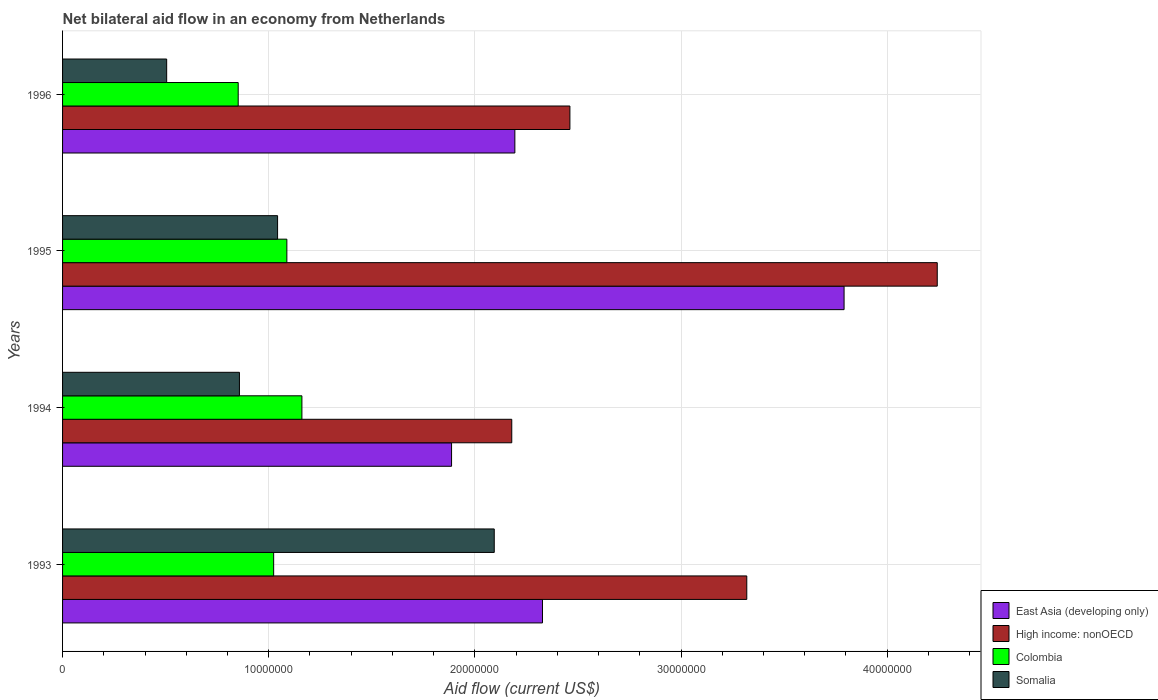How many different coloured bars are there?
Your response must be concise. 4. How many groups of bars are there?
Your response must be concise. 4. Are the number of bars on each tick of the Y-axis equal?
Make the answer very short. Yes. How many bars are there on the 3rd tick from the top?
Offer a very short reply. 4. In how many cases, is the number of bars for a given year not equal to the number of legend labels?
Your answer should be very brief. 0. What is the net bilateral aid flow in Colombia in 1994?
Ensure brevity in your answer.  1.16e+07. Across all years, what is the maximum net bilateral aid flow in Somalia?
Your answer should be very brief. 2.09e+07. Across all years, what is the minimum net bilateral aid flow in Somalia?
Ensure brevity in your answer.  5.05e+06. In which year was the net bilateral aid flow in Colombia maximum?
Your response must be concise. 1994. What is the total net bilateral aid flow in Colombia in the graph?
Your response must be concise. 4.12e+07. What is the difference between the net bilateral aid flow in Somalia in 1994 and that in 1995?
Provide a short and direct response. -1.85e+06. What is the difference between the net bilateral aid flow in Somalia in 1993 and the net bilateral aid flow in High income: nonOECD in 1996?
Provide a short and direct response. -3.67e+06. What is the average net bilateral aid flow in East Asia (developing only) per year?
Your answer should be compact. 2.55e+07. In the year 1993, what is the difference between the net bilateral aid flow in High income: nonOECD and net bilateral aid flow in Somalia?
Provide a short and direct response. 1.22e+07. In how many years, is the net bilateral aid flow in Colombia greater than 38000000 US$?
Keep it short and to the point. 0. What is the ratio of the net bilateral aid flow in East Asia (developing only) in 1994 to that in 1996?
Offer a terse response. 0.86. What is the difference between the highest and the second highest net bilateral aid flow in High income: nonOECD?
Your answer should be compact. 9.24e+06. What is the difference between the highest and the lowest net bilateral aid flow in High income: nonOECD?
Ensure brevity in your answer.  2.06e+07. Is the sum of the net bilateral aid flow in East Asia (developing only) in 1993 and 1996 greater than the maximum net bilateral aid flow in Somalia across all years?
Give a very brief answer. Yes. Is it the case that in every year, the sum of the net bilateral aid flow in East Asia (developing only) and net bilateral aid flow in High income: nonOECD is greater than the sum of net bilateral aid flow in Somalia and net bilateral aid flow in Colombia?
Give a very brief answer. Yes. What does the 2nd bar from the top in 1993 represents?
Provide a short and direct response. Colombia. What does the 2nd bar from the bottom in 1995 represents?
Make the answer very short. High income: nonOECD. How many bars are there?
Your answer should be very brief. 16. Are all the bars in the graph horizontal?
Your answer should be compact. Yes. What is the difference between two consecutive major ticks on the X-axis?
Provide a succinct answer. 1.00e+07. Are the values on the major ticks of X-axis written in scientific E-notation?
Offer a very short reply. No. Does the graph contain any zero values?
Make the answer very short. No. Does the graph contain grids?
Provide a succinct answer. Yes. How many legend labels are there?
Keep it short and to the point. 4. How are the legend labels stacked?
Your response must be concise. Vertical. What is the title of the graph?
Offer a terse response. Net bilateral aid flow in an economy from Netherlands. What is the label or title of the X-axis?
Keep it short and to the point. Aid flow (current US$). What is the label or title of the Y-axis?
Provide a short and direct response. Years. What is the Aid flow (current US$) of East Asia (developing only) in 1993?
Keep it short and to the point. 2.33e+07. What is the Aid flow (current US$) in High income: nonOECD in 1993?
Offer a terse response. 3.32e+07. What is the Aid flow (current US$) of Colombia in 1993?
Your response must be concise. 1.02e+07. What is the Aid flow (current US$) of Somalia in 1993?
Keep it short and to the point. 2.09e+07. What is the Aid flow (current US$) in East Asia (developing only) in 1994?
Offer a very short reply. 1.89e+07. What is the Aid flow (current US$) in High income: nonOECD in 1994?
Offer a terse response. 2.18e+07. What is the Aid flow (current US$) in Colombia in 1994?
Keep it short and to the point. 1.16e+07. What is the Aid flow (current US$) of Somalia in 1994?
Provide a succinct answer. 8.58e+06. What is the Aid flow (current US$) in East Asia (developing only) in 1995?
Provide a succinct answer. 3.79e+07. What is the Aid flow (current US$) of High income: nonOECD in 1995?
Offer a terse response. 4.24e+07. What is the Aid flow (current US$) in Colombia in 1995?
Give a very brief answer. 1.09e+07. What is the Aid flow (current US$) in Somalia in 1995?
Your response must be concise. 1.04e+07. What is the Aid flow (current US$) of East Asia (developing only) in 1996?
Give a very brief answer. 2.19e+07. What is the Aid flow (current US$) in High income: nonOECD in 1996?
Offer a very short reply. 2.46e+07. What is the Aid flow (current US$) in Colombia in 1996?
Offer a terse response. 8.52e+06. What is the Aid flow (current US$) in Somalia in 1996?
Your answer should be compact. 5.05e+06. Across all years, what is the maximum Aid flow (current US$) of East Asia (developing only)?
Keep it short and to the point. 3.79e+07. Across all years, what is the maximum Aid flow (current US$) in High income: nonOECD?
Make the answer very short. 4.24e+07. Across all years, what is the maximum Aid flow (current US$) in Colombia?
Your response must be concise. 1.16e+07. Across all years, what is the maximum Aid flow (current US$) of Somalia?
Your answer should be compact. 2.09e+07. Across all years, what is the minimum Aid flow (current US$) in East Asia (developing only)?
Keep it short and to the point. 1.89e+07. Across all years, what is the minimum Aid flow (current US$) of High income: nonOECD?
Your response must be concise. 2.18e+07. Across all years, what is the minimum Aid flow (current US$) of Colombia?
Your answer should be very brief. 8.52e+06. Across all years, what is the minimum Aid flow (current US$) in Somalia?
Offer a terse response. 5.05e+06. What is the total Aid flow (current US$) in East Asia (developing only) in the graph?
Make the answer very short. 1.02e+08. What is the total Aid flow (current US$) in High income: nonOECD in the graph?
Make the answer very short. 1.22e+08. What is the total Aid flow (current US$) of Colombia in the graph?
Give a very brief answer. 4.12e+07. What is the total Aid flow (current US$) of Somalia in the graph?
Ensure brevity in your answer.  4.50e+07. What is the difference between the Aid flow (current US$) in East Asia (developing only) in 1993 and that in 1994?
Keep it short and to the point. 4.41e+06. What is the difference between the Aid flow (current US$) of High income: nonOECD in 1993 and that in 1994?
Your answer should be compact. 1.14e+07. What is the difference between the Aid flow (current US$) of Colombia in 1993 and that in 1994?
Keep it short and to the point. -1.37e+06. What is the difference between the Aid flow (current US$) in Somalia in 1993 and that in 1994?
Your answer should be very brief. 1.24e+07. What is the difference between the Aid flow (current US$) in East Asia (developing only) in 1993 and that in 1995?
Keep it short and to the point. -1.46e+07. What is the difference between the Aid flow (current US$) of High income: nonOECD in 1993 and that in 1995?
Give a very brief answer. -9.24e+06. What is the difference between the Aid flow (current US$) of Colombia in 1993 and that in 1995?
Keep it short and to the point. -6.40e+05. What is the difference between the Aid flow (current US$) in Somalia in 1993 and that in 1995?
Your answer should be very brief. 1.05e+07. What is the difference between the Aid flow (current US$) in East Asia (developing only) in 1993 and that in 1996?
Give a very brief answer. 1.34e+06. What is the difference between the Aid flow (current US$) in High income: nonOECD in 1993 and that in 1996?
Offer a terse response. 8.58e+06. What is the difference between the Aid flow (current US$) of Colombia in 1993 and that in 1996?
Your response must be concise. 1.72e+06. What is the difference between the Aid flow (current US$) of Somalia in 1993 and that in 1996?
Your response must be concise. 1.59e+07. What is the difference between the Aid flow (current US$) of East Asia (developing only) in 1994 and that in 1995?
Ensure brevity in your answer.  -1.90e+07. What is the difference between the Aid flow (current US$) of High income: nonOECD in 1994 and that in 1995?
Offer a very short reply. -2.06e+07. What is the difference between the Aid flow (current US$) of Colombia in 1994 and that in 1995?
Ensure brevity in your answer.  7.30e+05. What is the difference between the Aid flow (current US$) in Somalia in 1994 and that in 1995?
Provide a succinct answer. -1.85e+06. What is the difference between the Aid flow (current US$) in East Asia (developing only) in 1994 and that in 1996?
Provide a short and direct response. -3.07e+06. What is the difference between the Aid flow (current US$) of High income: nonOECD in 1994 and that in 1996?
Give a very brief answer. -2.82e+06. What is the difference between the Aid flow (current US$) in Colombia in 1994 and that in 1996?
Provide a succinct answer. 3.09e+06. What is the difference between the Aid flow (current US$) in Somalia in 1994 and that in 1996?
Keep it short and to the point. 3.53e+06. What is the difference between the Aid flow (current US$) of East Asia (developing only) in 1995 and that in 1996?
Your answer should be very brief. 1.60e+07. What is the difference between the Aid flow (current US$) in High income: nonOECD in 1995 and that in 1996?
Provide a short and direct response. 1.78e+07. What is the difference between the Aid flow (current US$) of Colombia in 1995 and that in 1996?
Ensure brevity in your answer.  2.36e+06. What is the difference between the Aid flow (current US$) in Somalia in 1995 and that in 1996?
Make the answer very short. 5.38e+06. What is the difference between the Aid flow (current US$) of East Asia (developing only) in 1993 and the Aid flow (current US$) of High income: nonOECD in 1994?
Provide a short and direct response. 1.49e+06. What is the difference between the Aid flow (current US$) of East Asia (developing only) in 1993 and the Aid flow (current US$) of Colombia in 1994?
Keep it short and to the point. 1.17e+07. What is the difference between the Aid flow (current US$) of East Asia (developing only) in 1993 and the Aid flow (current US$) of Somalia in 1994?
Your response must be concise. 1.47e+07. What is the difference between the Aid flow (current US$) in High income: nonOECD in 1993 and the Aid flow (current US$) in Colombia in 1994?
Your answer should be very brief. 2.16e+07. What is the difference between the Aid flow (current US$) of High income: nonOECD in 1993 and the Aid flow (current US$) of Somalia in 1994?
Your answer should be very brief. 2.46e+07. What is the difference between the Aid flow (current US$) in Colombia in 1993 and the Aid flow (current US$) in Somalia in 1994?
Ensure brevity in your answer.  1.66e+06. What is the difference between the Aid flow (current US$) of East Asia (developing only) in 1993 and the Aid flow (current US$) of High income: nonOECD in 1995?
Give a very brief answer. -1.92e+07. What is the difference between the Aid flow (current US$) of East Asia (developing only) in 1993 and the Aid flow (current US$) of Colombia in 1995?
Your answer should be compact. 1.24e+07. What is the difference between the Aid flow (current US$) of East Asia (developing only) in 1993 and the Aid flow (current US$) of Somalia in 1995?
Provide a succinct answer. 1.28e+07. What is the difference between the Aid flow (current US$) in High income: nonOECD in 1993 and the Aid flow (current US$) in Colombia in 1995?
Offer a terse response. 2.23e+07. What is the difference between the Aid flow (current US$) in High income: nonOECD in 1993 and the Aid flow (current US$) in Somalia in 1995?
Provide a short and direct response. 2.28e+07. What is the difference between the Aid flow (current US$) of Colombia in 1993 and the Aid flow (current US$) of Somalia in 1995?
Make the answer very short. -1.90e+05. What is the difference between the Aid flow (current US$) in East Asia (developing only) in 1993 and the Aid flow (current US$) in High income: nonOECD in 1996?
Make the answer very short. -1.33e+06. What is the difference between the Aid flow (current US$) of East Asia (developing only) in 1993 and the Aid flow (current US$) of Colombia in 1996?
Provide a succinct answer. 1.48e+07. What is the difference between the Aid flow (current US$) in East Asia (developing only) in 1993 and the Aid flow (current US$) in Somalia in 1996?
Offer a very short reply. 1.82e+07. What is the difference between the Aid flow (current US$) of High income: nonOECD in 1993 and the Aid flow (current US$) of Colombia in 1996?
Provide a succinct answer. 2.47e+07. What is the difference between the Aid flow (current US$) in High income: nonOECD in 1993 and the Aid flow (current US$) in Somalia in 1996?
Your response must be concise. 2.81e+07. What is the difference between the Aid flow (current US$) in Colombia in 1993 and the Aid flow (current US$) in Somalia in 1996?
Make the answer very short. 5.19e+06. What is the difference between the Aid flow (current US$) of East Asia (developing only) in 1994 and the Aid flow (current US$) of High income: nonOECD in 1995?
Your answer should be compact. -2.36e+07. What is the difference between the Aid flow (current US$) in East Asia (developing only) in 1994 and the Aid flow (current US$) in Colombia in 1995?
Ensure brevity in your answer.  7.99e+06. What is the difference between the Aid flow (current US$) of East Asia (developing only) in 1994 and the Aid flow (current US$) of Somalia in 1995?
Provide a succinct answer. 8.44e+06. What is the difference between the Aid flow (current US$) of High income: nonOECD in 1994 and the Aid flow (current US$) of Colombia in 1995?
Your response must be concise. 1.09e+07. What is the difference between the Aid flow (current US$) in High income: nonOECD in 1994 and the Aid flow (current US$) in Somalia in 1995?
Make the answer very short. 1.14e+07. What is the difference between the Aid flow (current US$) in Colombia in 1994 and the Aid flow (current US$) in Somalia in 1995?
Your answer should be very brief. 1.18e+06. What is the difference between the Aid flow (current US$) of East Asia (developing only) in 1994 and the Aid flow (current US$) of High income: nonOECD in 1996?
Your response must be concise. -5.74e+06. What is the difference between the Aid flow (current US$) of East Asia (developing only) in 1994 and the Aid flow (current US$) of Colombia in 1996?
Give a very brief answer. 1.04e+07. What is the difference between the Aid flow (current US$) in East Asia (developing only) in 1994 and the Aid flow (current US$) in Somalia in 1996?
Your response must be concise. 1.38e+07. What is the difference between the Aid flow (current US$) of High income: nonOECD in 1994 and the Aid flow (current US$) of Colombia in 1996?
Offer a terse response. 1.33e+07. What is the difference between the Aid flow (current US$) of High income: nonOECD in 1994 and the Aid flow (current US$) of Somalia in 1996?
Offer a terse response. 1.67e+07. What is the difference between the Aid flow (current US$) of Colombia in 1994 and the Aid flow (current US$) of Somalia in 1996?
Keep it short and to the point. 6.56e+06. What is the difference between the Aid flow (current US$) of East Asia (developing only) in 1995 and the Aid flow (current US$) of High income: nonOECD in 1996?
Give a very brief answer. 1.33e+07. What is the difference between the Aid flow (current US$) of East Asia (developing only) in 1995 and the Aid flow (current US$) of Colombia in 1996?
Provide a short and direct response. 2.94e+07. What is the difference between the Aid flow (current US$) in East Asia (developing only) in 1995 and the Aid flow (current US$) in Somalia in 1996?
Your answer should be very brief. 3.29e+07. What is the difference between the Aid flow (current US$) in High income: nonOECD in 1995 and the Aid flow (current US$) in Colombia in 1996?
Provide a succinct answer. 3.39e+07. What is the difference between the Aid flow (current US$) in High income: nonOECD in 1995 and the Aid flow (current US$) in Somalia in 1996?
Your answer should be very brief. 3.74e+07. What is the difference between the Aid flow (current US$) of Colombia in 1995 and the Aid flow (current US$) of Somalia in 1996?
Offer a very short reply. 5.83e+06. What is the average Aid flow (current US$) in East Asia (developing only) per year?
Make the answer very short. 2.55e+07. What is the average Aid flow (current US$) of High income: nonOECD per year?
Give a very brief answer. 3.05e+07. What is the average Aid flow (current US$) in Colombia per year?
Your answer should be very brief. 1.03e+07. What is the average Aid flow (current US$) of Somalia per year?
Give a very brief answer. 1.12e+07. In the year 1993, what is the difference between the Aid flow (current US$) in East Asia (developing only) and Aid flow (current US$) in High income: nonOECD?
Your answer should be compact. -9.91e+06. In the year 1993, what is the difference between the Aid flow (current US$) in East Asia (developing only) and Aid flow (current US$) in Colombia?
Offer a terse response. 1.30e+07. In the year 1993, what is the difference between the Aid flow (current US$) in East Asia (developing only) and Aid flow (current US$) in Somalia?
Keep it short and to the point. 2.34e+06. In the year 1993, what is the difference between the Aid flow (current US$) in High income: nonOECD and Aid flow (current US$) in Colombia?
Provide a succinct answer. 2.30e+07. In the year 1993, what is the difference between the Aid flow (current US$) of High income: nonOECD and Aid flow (current US$) of Somalia?
Offer a very short reply. 1.22e+07. In the year 1993, what is the difference between the Aid flow (current US$) in Colombia and Aid flow (current US$) in Somalia?
Your answer should be very brief. -1.07e+07. In the year 1994, what is the difference between the Aid flow (current US$) in East Asia (developing only) and Aid flow (current US$) in High income: nonOECD?
Provide a succinct answer. -2.92e+06. In the year 1994, what is the difference between the Aid flow (current US$) of East Asia (developing only) and Aid flow (current US$) of Colombia?
Provide a short and direct response. 7.26e+06. In the year 1994, what is the difference between the Aid flow (current US$) in East Asia (developing only) and Aid flow (current US$) in Somalia?
Ensure brevity in your answer.  1.03e+07. In the year 1994, what is the difference between the Aid flow (current US$) in High income: nonOECD and Aid flow (current US$) in Colombia?
Your response must be concise. 1.02e+07. In the year 1994, what is the difference between the Aid flow (current US$) of High income: nonOECD and Aid flow (current US$) of Somalia?
Your answer should be compact. 1.32e+07. In the year 1994, what is the difference between the Aid flow (current US$) of Colombia and Aid flow (current US$) of Somalia?
Offer a very short reply. 3.03e+06. In the year 1995, what is the difference between the Aid flow (current US$) of East Asia (developing only) and Aid flow (current US$) of High income: nonOECD?
Your answer should be very brief. -4.52e+06. In the year 1995, what is the difference between the Aid flow (current US$) of East Asia (developing only) and Aid flow (current US$) of Colombia?
Keep it short and to the point. 2.70e+07. In the year 1995, what is the difference between the Aid flow (current US$) of East Asia (developing only) and Aid flow (current US$) of Somalia?
Your answer should be compact. 2.75e+07. In the year 1995, what is the difference between the Aid flow (current US$) in High income: nonOECD and Aid flow (current US$) in Colombia?
Give a very brief answer. 3.16e+07. In the year 1995, what is the difference between the Aid flow (current US$) of High income: nonOECD and Aid flow (current US$) of Somalia?
Make the answer very short. 3.20e+07. In the year 1996, what is the difference between the Aid flow (current US$) of East Asia (developing only) and Aid flow (current US$) of High income: nonOECD?
Give a very brief answer. -2.67e+06. In the year 1996, what is the difference between the Aid flow (current US$) of East Asia (developing only) and Aid flow (current US$) of Colombia?
Your answer should be very brief. 1.34e+07. In the year 1996, what is the difference between the Aid flow (current US$) of East Asia (developing only) and Aid flow (current US$) of Somalia?
Make the answer very short. 1.69e+07. In the year 1996, what is the difference between the Aid flow (current US$) in High income: nonOECD and Aid flow (current US$) in Colombia?
Your answer should be compact. 1.61e+07. In the year 1996, what is the difference between the Aid flow (current US$) in High income: nonOECD and Aid flow (current US$) in Somalia?
Provide a succinct answer. 1.96e+07. In the year 1996, what is the difference between the Aid flow (current US$) in Colombia and Aid flow (current US$) in Somalia?
Provide a succinct answer. 3.47e+06. What is the ratio of the Aid flow (current US$) in East Asia (developing only) in 1993 to that in 1994?
Ensure brevity in your answer.  1.23. What is the ratio of the Aid flow (current US$) in High income: nonOECD in 1993 to that in 1994?
Your answer should be very brief. 1.52. What is the ratio of the Aid flow (current US$) of Colombia in 1993 to that in 1994?
Provide a short and direct response. 0.88. What is the ratio of the Aid flow (current US$) of Somalia in 1993 to that in 1994?
Make the answer very short. 2.44. What is the ratio of the Aid flow (current US$) in East Asia (developing only) in 1993 to that in 1995?
Give a very brief answer. 0.61. What is the ratio of the Aid flow (current US$) in High income: nonOECD in 1993 to that in 1995?
Offer a terse response. 0.78. What is the ratio of the Aid flow (current US$) of Colombia in 1993 to that in 1995?
Keep it short and to the point. 0.94. What is the ratio of the Aid flow (current US$) in Somalia in 1993 to that in 1995?
Offer a terse response. 2.01. What is the ratio of the Aid flow (current US$) of East Asia (developing only) in 1993 to that in 1996?
Offer a very short reply. 1.06. What is the ratio of the Aid flow (current US$) in High income: nonOECD in 1993 to that in 1996?
Offer a very short reply. 1.35. What is the ratio of the Aid flow (current US$) in Colombia in 1993 to that in 1996?
Your answer should be very brief. 1.2. What is the ratio of the Aid flow (current US$) in Somalia in 1993 to that in 1996?
Offer a terse response. 4.15. What is the ratio of the Aid flow (current US$) in East Asia (developing only) in 1994 to that in 1995?
Your response must be concise. 0.5. What is the ratio of the Aid flow (current US$) in High income: nonOECD in 1994 to that in 1995?
Provide a short and direct response. 0.51. What is the ratio of the Aid flow (current US$) in Colombia in 1994 to that in 1995?
Offer a very short reply. 1.07. What is the ratio of the Aid flow (current US$) of Somalia in 1994 to that in 1995?
Ensure brevity in your answer.  0.82. What is the ratio of the Aid flow (current US$) in East Asia (developing only) in 1994 to that in 1996?
Your answer should be very brief. 0.86. What is the ratio of the Aid flow (current US$) in High income: nonOECD in 1994 to that in 1996?
Keep it short and to the point. 0.89. What is the ratio of the Aid flow (current US$) in Colombia in 1994 to that in 1996?
Provide a short and direct response. 1.36. What is the ratio of the Aid flow (current US$) of Somalia in 1994 to that in 1996?
Make the answer very short. 1.7. What is the ratio of the Aid flow (current US$) in East Asia (developing only) in 1995 to that in 1996?
Your response must be concise. 1.73. What is the ratio of the Aid flow (current US$) in High income: nonOECD in 1995 to that in 1996?
Provide a short and direct response. 1.72. What is the ratio of the Aid flow (current US$) of Colombia in 1995 to that in 1996?
Your answer should be very brief. 1.28. What is the ratio of the Aid flow (current US$) in Somalia in 1995 to that in 1996?
Provide a short and direct response. 2.07. What is the difference between the highest and the second highest Aid flow (current US$) in East Asia (developing only)?
Give a very brief answer. 1.46e+07. What is the difference between the highest and the second highest Aid flow (current US$) of High income: nonOECD?
Provide a short and direct response. 9.24e+06. What is the difference between the highest and the second highest Aid flow (current US$) in Colombia?
Offer a terse response. 7.30e+05. What is the difference between the highest and the second highest Aid flow (current US$) in Somalia?
Offer a terse response. 1.05e+07. What is the difference between the highest and the lowest Aid flow (current US$) of East Asia (developing only)?
Ensure brevity in your answer.  1.90e+07. What is the difference between the highest and the lowest Aid flow (current US$) of High income: nonOECD?
Make the answer very short. 2.06e+07. What is the difference between the highest and the lowest Aid flow (current US$) of Colombia?
Your answer should be very brief. 3.09e+06. What is the difference between the highest and the lowest Aid flow (current US$) in Somalia?
Provide a short and direct response. 1.59e+07. 